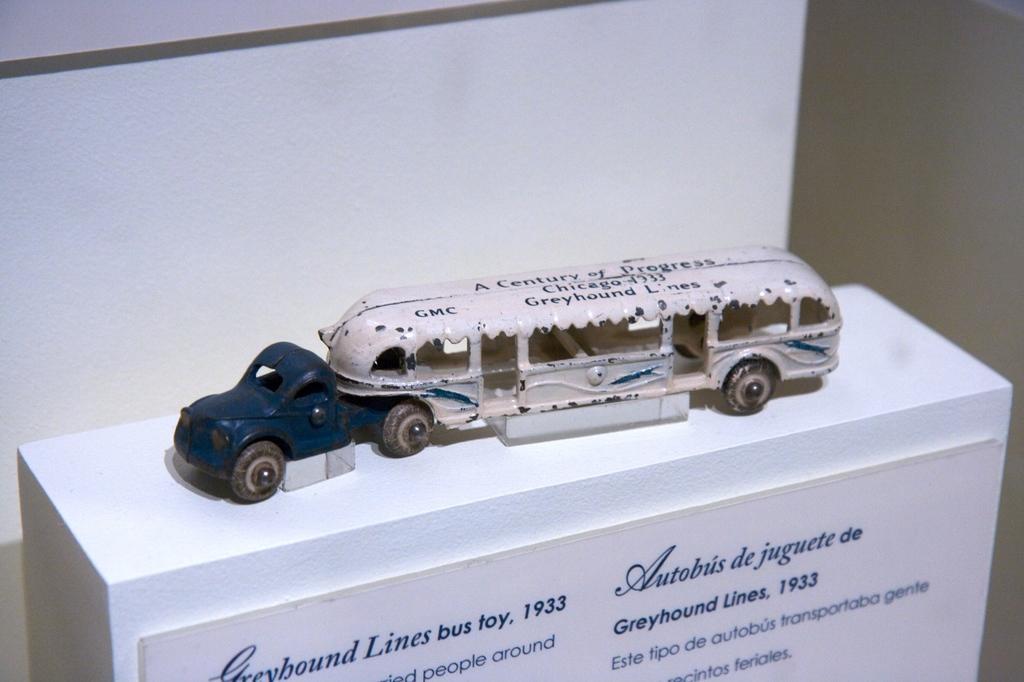Describe this image in one or two sentences. In this image I can see a white colour thing and on it I can see a toy vehicle. On the bottom side of this image I can see a white colour board and on it I can see something is written. 